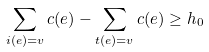<formula> <loc_0><loc_0><loc_500><loc_500>\sum _ { i ( e ) = v } c ( e ) - \sum _ { t ( e ) = v } c ( e ) \geq h _ { 0 }</formula> 